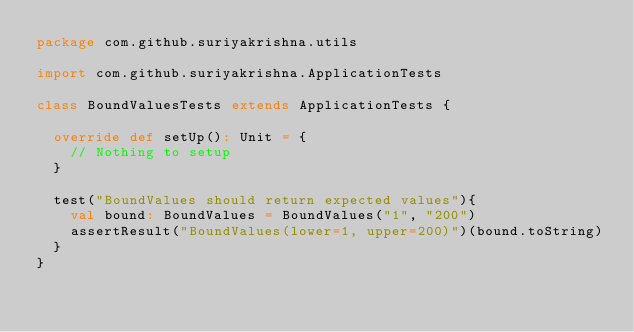<code> <loc_0><loc_0><loc_500><loc_500><_Scala_>package com.github.suriyakrishna.utils

import com.github.suriyakrishna.ApplicationTests

class BoundValuesTests extends ApplicationTests {

  override def setUp(): Unit = {
    // Nothing to setup
  }

  test("BoundValues should return expected values"){
    val bound: BoundValues = BoundValues("1", "200")
    assertResult("BoundValues(lower=1, upper=200)")(bound.toString)
  }
}
</code> 